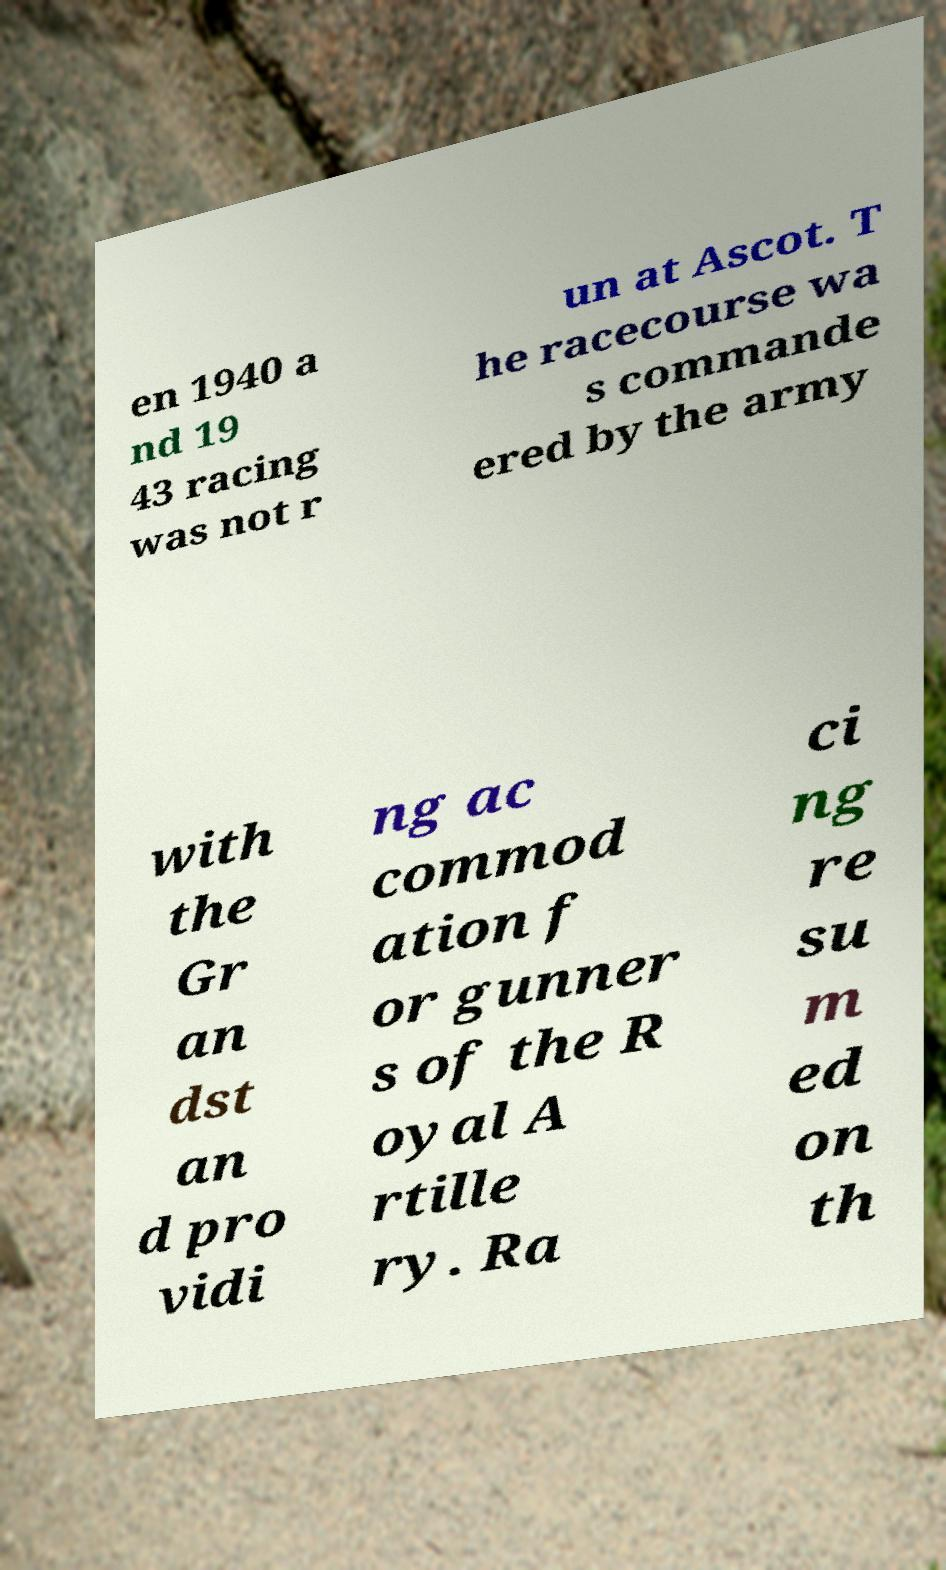Could you assist in decoding the text presented in this image and type it out clearly? en 1940 a nd 19 43 racing was not r un at Ascot. T he racecourse wa s commande ered by the army with the Gr an dst an d pro vidi ng ac commod ation f or gunner s of the R oyal A rtille ry. Ra ci ng re su m ed on th 